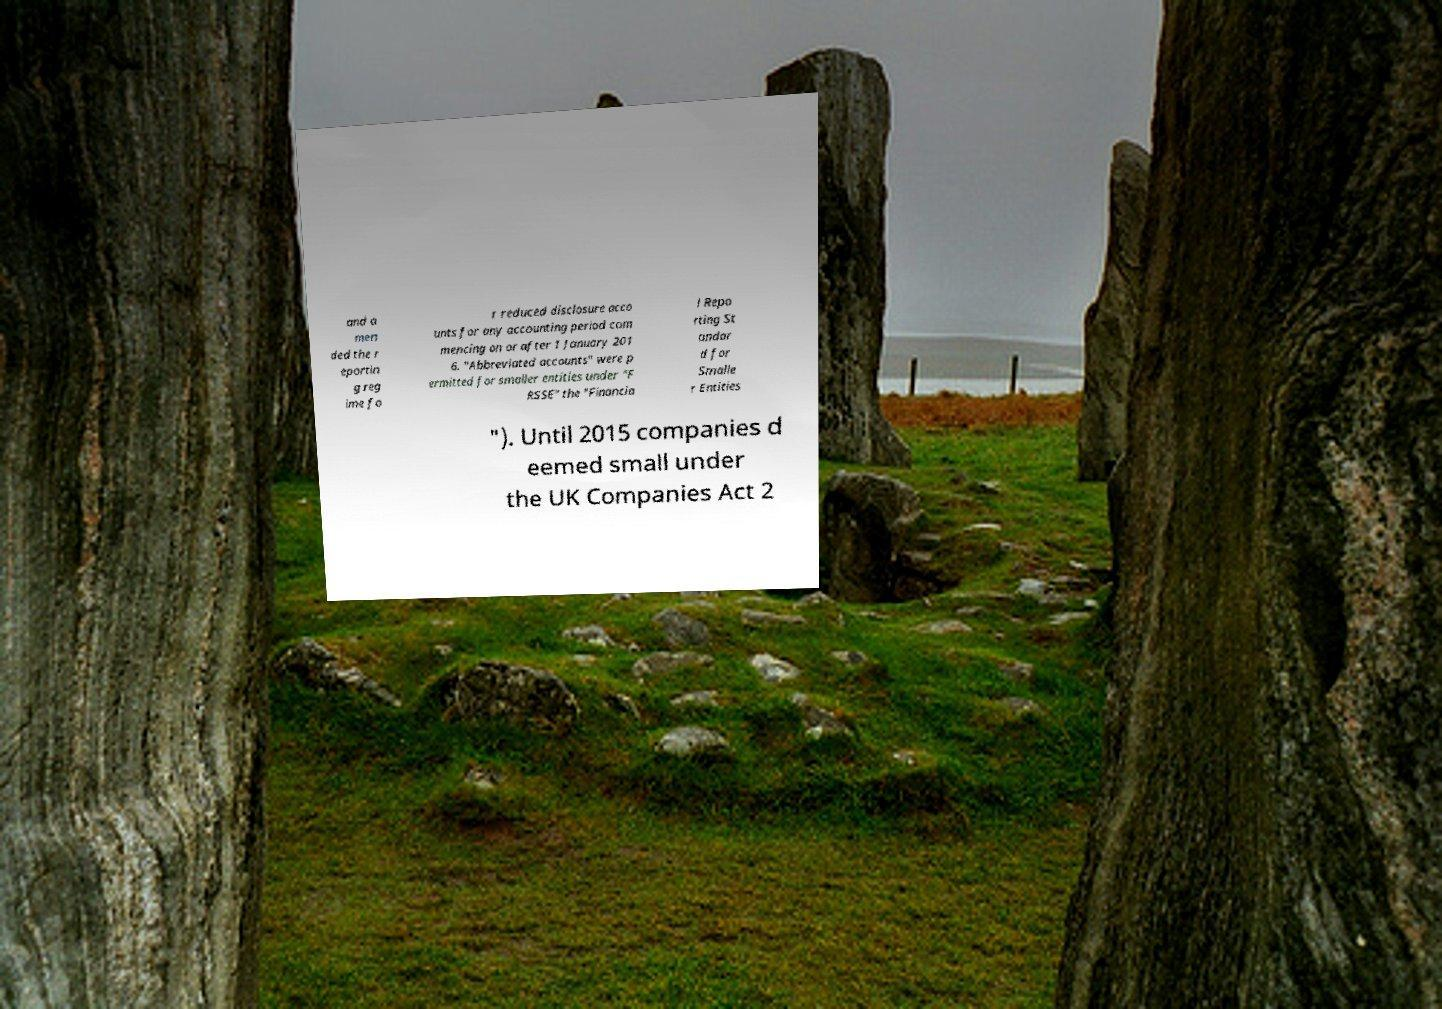Please read and relay the text visible in this image. What does it say? and a men ded the r eportin g reg ime fo r reduced disclosure acco unts for any accounting period com mencing on or after 1 January 201 6. "Abbreviated accounts" were p ermitted for smaller entities under "F RSSE" the "Financia l Repo rting St andar d for Smalle r Entities "). Until 2015 companies d eemed small under the UK Companies Act 2 